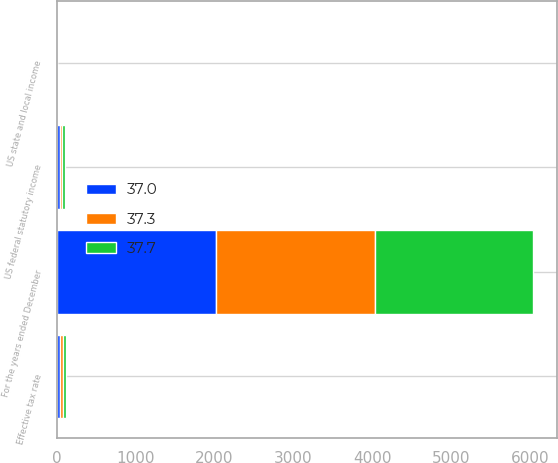<chart> <loc_0><loc_0><loc_500><loc_500><stacked_bar_chart><ecel><fcel>For the years ended December<fcel>US federal statutory income<fcel>US state and local income<fcel>Effective tax rate<nl><fcel>37<fcel>2015<fcel>35<fcel>2.3<fcel>37.3<nl><fcel>37.3<fcel>2014<fcel>35<fcel>2.5<fcel>37.7<nl><fcel>37.7<fcel>2013<fcel>35<fcel>1.9<fcel>37<nl></chart> 